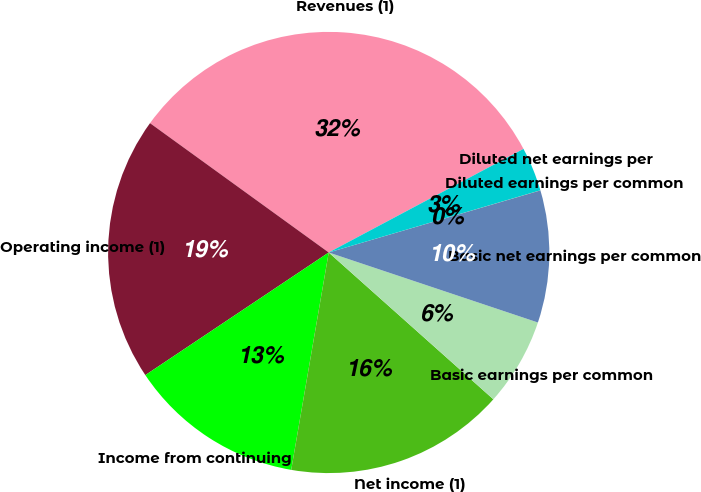Convert chart. <chart><loc_0><loc_0><loc_500><loc_500><pie_chart><fcel>Revenues (1)<fcel>Operating income (1)<fcel>Income from continuing<fcel>Net income (1)<fcel>Basic earnings per common<fcel>Basic net earnings per common<fcel>Diluted earnings per common<fcel>Diluted net earnings per<nl><fcel>32.25%<fcel>19.35%<fcel>12.9%<fcel>16.13%<fcel>6.45%<fcel>9.68%<fcel>0.01%<fcel>3.23%<nl></chart> 